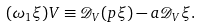<formula> <loc_0><loc_0><loc_500><loc_500>( \omega _ { 1 } \xi ) V \equiv \mathcal { D } _ { V } ( p \xi ) - a { \mathcal { D } } _ { V } \xi .</formula> 